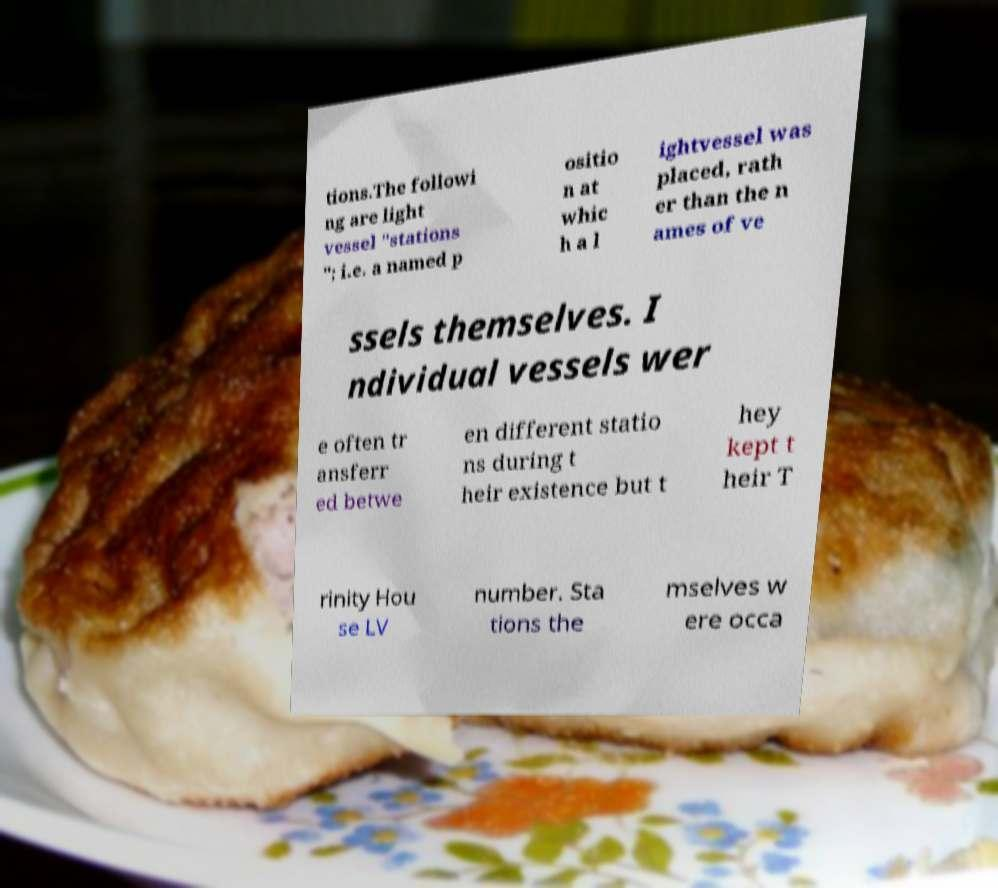What messages or text are displayed in this image? I need them in a readable, typed format. tions.The followi ng are light vessel "stations "; i.e. a named p ositio n at whic h a l ightvessel was placed, rath er than the n ames of ve ssels themselves. I ndividual vessels wer e often tr ansferr ed betwe en different statio ns during t heir existence but t hey kept t heir T rinity Hou se LV number. Sta tions the mselves w ere occa 